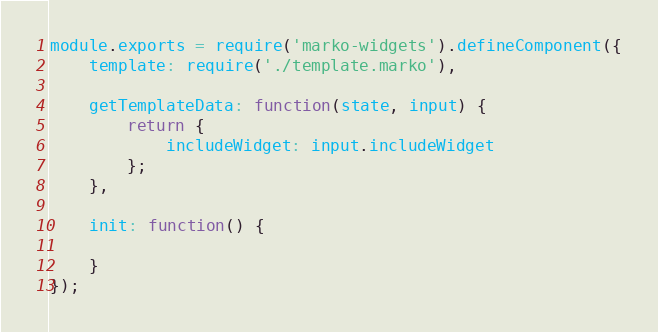Convert code to text. <code><loc_0><loc_0><loc_500><loc_500><_JavaScript_>module.exports = require('marko-widgets').defineComponent({
    template: require('./template.marko'),

    getTemplateData: function(state, input) {
        return {
            includeWidget: input.includeWidget
        };
    },

    init: function() {

    }
});</code> 